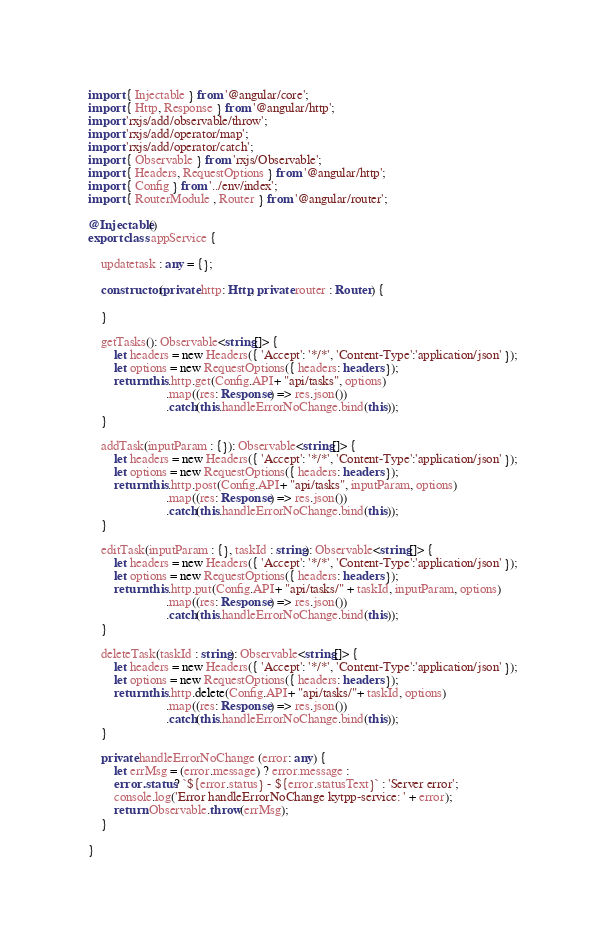Convert code to text. <code><loc_0><loc_0><loc_500><loc_500><_TypeScript_>import { Injectable } from '@angular/core';
import { Http, Response } from '@angular/http';
import 'rxjs/add/observable/throw';
import 'rxjs/add/operator/map';
import 'rxjs/add/operator/catch';
import { Observable } from 'rxjs/Observable';  
import { Headers, RequestOptions } from '@angular/http';
import { Config } from '../env/index';
import { RouterModule , Router } from '@angular/router';

@Injectable()
export class appService {
  
    updatetask : any = {};
    
    constructor(private http: Http, private router : Router) {

    } 

    getTasks(): Observable<string[]> {
        let headers = new Headers({ 'Accept': '*/*', 'Content-Type':'application/json' });
        let options = new RequestOptions({ headers: headers });
        return this.http.get(Config.API+ "api/tasks", options)
                        .map((res: Response) => res.json())
                        .catch(this.handleErrorNoChange.bind(this));
    }

    addTask(inputParam : {}): Observable<string[]> {
        let headers = new Headers({ 'Accept': '*/*', 'Content-Type':'application/json' });
        let options = new RequestOptions({ headers: headers });
        return this.http.post(Config.API+ "api/tasks", inputParam, options)
                        .map((res: Response) => res.json())
                        .catch(this.handleErrorNoChange.bind(this));
    }

    editTask(inputParam : {}, taskId : string): Observable<string[]> {
        let headers = new Headers({ 'Accept': '*/*', 'Content-Type':'application/json' });
        let options = new RequestOptions({ headers: headers });
        return this.http.put(Config.API+ "api/tasks/" + taskId, inputParam, options)
                        .map((res: Response) => res.json())
                        .catch(this.handleErrorNoChange.bind(this));
    }

    deleteTask(taskId : string): Observable<string[]> {
        let headers = new Headers({ 'Accept': '*/*', 'Content-Type':'application/json' });
        let options = new RequestOptions({ headers: headers });
        return this.http.delete(Config.API+ "api/tasks/"+ taskId, options)
                        .map((res: Response) => res.json())
                        .catch(this.handleErrorNoChange.bind(this));
    }

    private handleErrorNoChange (error: any) {
        let errMsg = (error.message) ? error.message :
        error.status ? `${error.status} - ${error.statusText}` : 'Server error';
        console.log('Error handleErrorNoChange kytpp-service: ' + error);
        return Observable.throw(errMsg);
    }

}</code> 